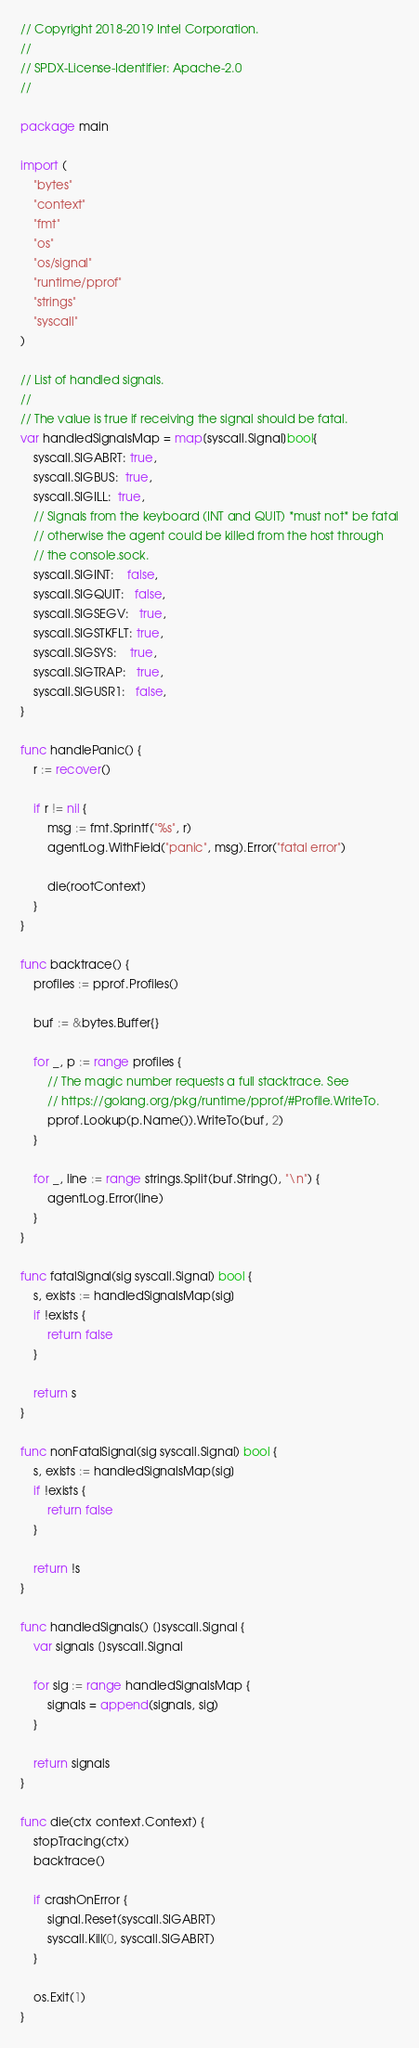<code> <loc_0><loc_0><loc_500><loc_500><_Go_>// Copyright 2018-2019 Intel Corporation.
//
// SPDX-License-Identifier: Apache-2.0
//

package main

import (
	"bytes"
	"context"
	"fmt"
	"os"
	"os/signal"
	"runtime/pprof"
	"strings"
	"syscall"
)

// List of handled signals.
//
// The value is true if receiving the signal should be fatal.
var handledSignalsMap = map[syscall.Signal]bool{
	syscall.SIGABRT: true,
	syscall.SIGBUS:  true,
	syscall.SIGILL:  true,
	// Signals from the keyboard (INT and QUIT) *must not* be fatal
	// otherwise the agent could be killed from the host through
	// the console.sock.
	syscall.SIGINT:    false,
	syscall.SIGQUIT:   false,
	syscall.SIGSEGV:   true,
	syscall.SIGSTKFLT: true,
	syscall.SIGSYS:    true,
	syscall.SIGTRAP:   true,
	syscall.SIGUSR1:   false,
}

func handlePanic() {
	r := recover()

	if r != nil {
		msg := fmt.Sprintf("%s", r)
		agentLog.WithField("panic", msg).Error("fatal error")

		die(rootContext)
	}
}

func backtrace() {
	profiles := pprof.Profiles()

	buf := &bytes.Buffer{}

	for _, p := range profiles {
		// The magic number requests a full stacktrace. See
		// https://golang.org/pkg/runtime/pprof/#Profile.WriteTo.
		pprof.Lookup(p.Name()).WriteTo(buf, 2)
	}

	for _, line := range strings.Split(buf.String(), "\n") {
		agentLog.Error(line)
	}
}

func fatalSignal(sig syscall.Signal) bool {
	s, exists := handledSignalsMap[sig]
	if !exists {
		return false
	}

	return s
}

func nonFatalSignal(sig syscall.Signal) bool {
	s, exists := handledSignalsMap[sig]
	if !exists {
		return false
	}

	return !s
}

func handledSignals() []syscall.Signal {
	var signals []syscall.Signal

	for sig := range handledSignalsMap {
		signals = append(signals, sig)
	}

	return signals
}

func die(ctx context.Context) {
	stopTracing(ctx)
	backtrace()

	if crashOnError {
		signal.Reset(syscall.SIGABRT)
		syscall.Kill(0, syscall.SIGABRT)
	}

	os.Exit(1)
}
</code> 